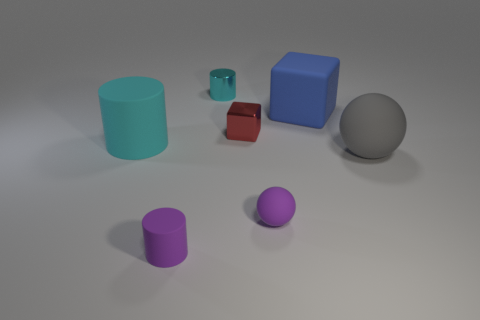The gray object has what shape?
Offer a very short reply. Sphere. Does the cube behind the tiny red metal thing have the same material as the tiny sphere?
Your response must be concise. Yes. There is a cyan thing right of the small cylinder that is in front of the small cyan metallic cylinder; what size is it?
Offer a very short reply. Small. What is the color of the object that is to the left of the small red block and behind the red thing?
Provide a succinct answer. Cyan. There is a purple cylinder that is the same size as the cyan metallic cylinder; what material is it?
Your response must be concise. Rubber. What number of other objects are there of the same material as the small purple cylinder?
Provide a succinct answer. 4. Is the color of the cylinder behind the big cyan thing the same as the small cylinder in front of the big rubber cylinder?
Offer a terse response. No. There is a cyan object that is in front of the cube in front of the blue thing; what shape is it?
Make the answer very short. Cylinder. How many other objects are the same color as the small metal block?
Your answer should be compact. 0. Does the object that is behind the large cube have the same material as the tiny cylinder that is in front of the shiny cube?
Your response must be concise. No. 